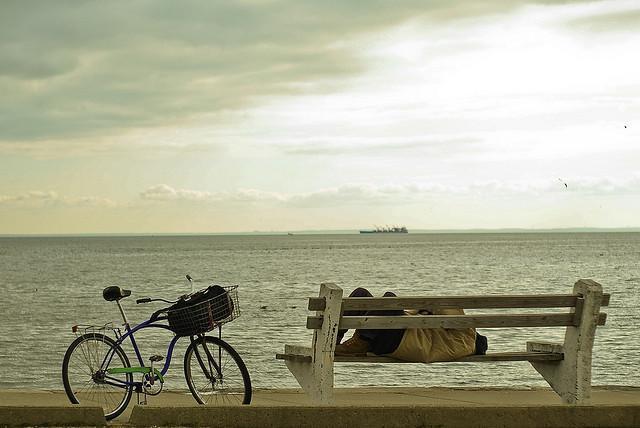How many benches are there?
Give a very brief answer. 1. How many pieces of fruit in the bowl are green?
Give a very brief answer. 0. 